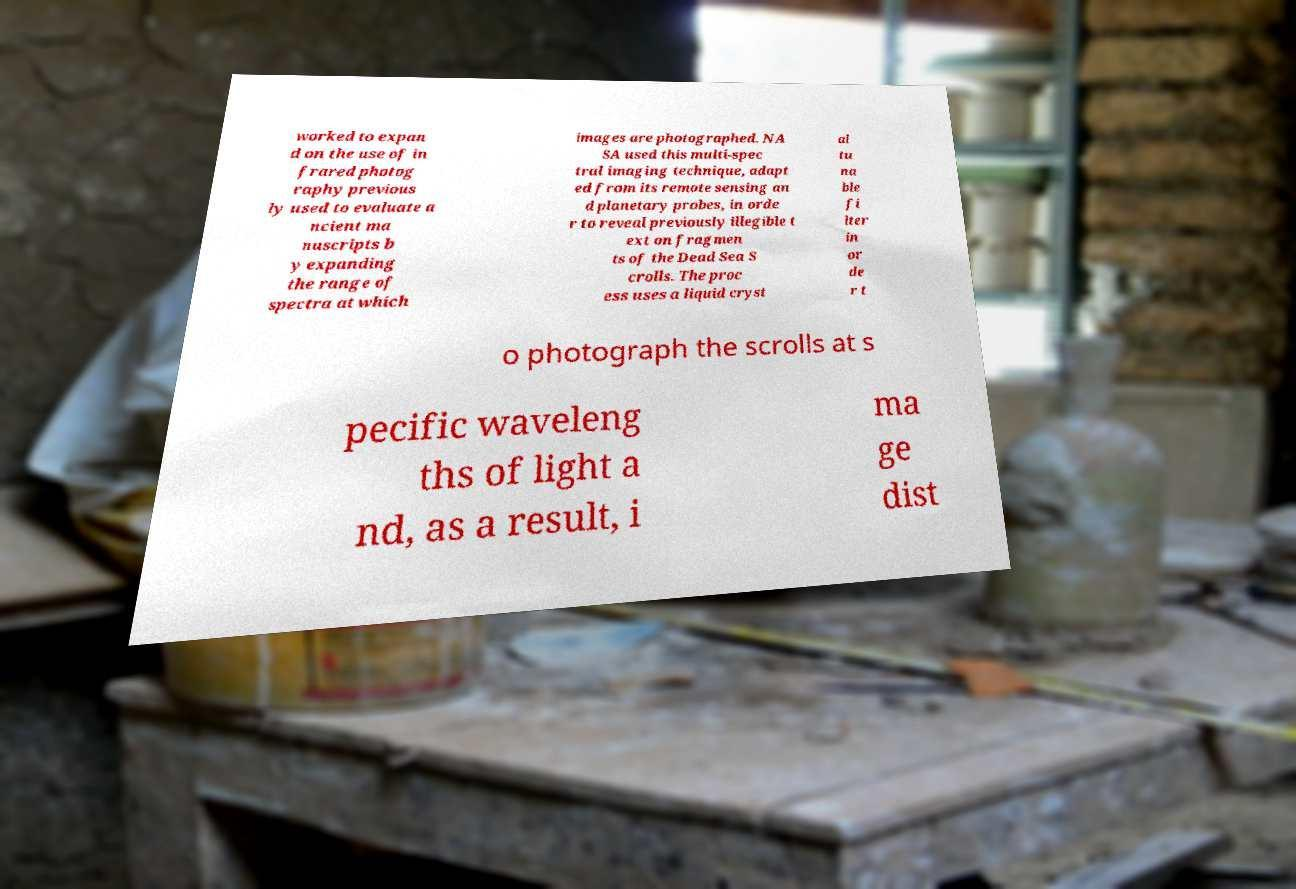Can you read and provide the text displayed in the image?This photo seems to have some interesting text. Can you extract and type it out for me? worked to expan d on the use of in frared photog raphy previous ly used to evaluate a ncient ma nuscripts b y expanding the range of spectra at which images are photographed. NA SA used this multi-spec tral imaging technique, adapt ed from its remote sensing an d planetary probes, in orde r to reveal previously illegible t ext on fragmen ts of the Dead Sea S crolls. The proc ess uses a liquid cryst al tu na ble fi lter in or de r t o photograph the scrolls at s pecific waveleng ths of light a nd, as a result, i ma ge dist 